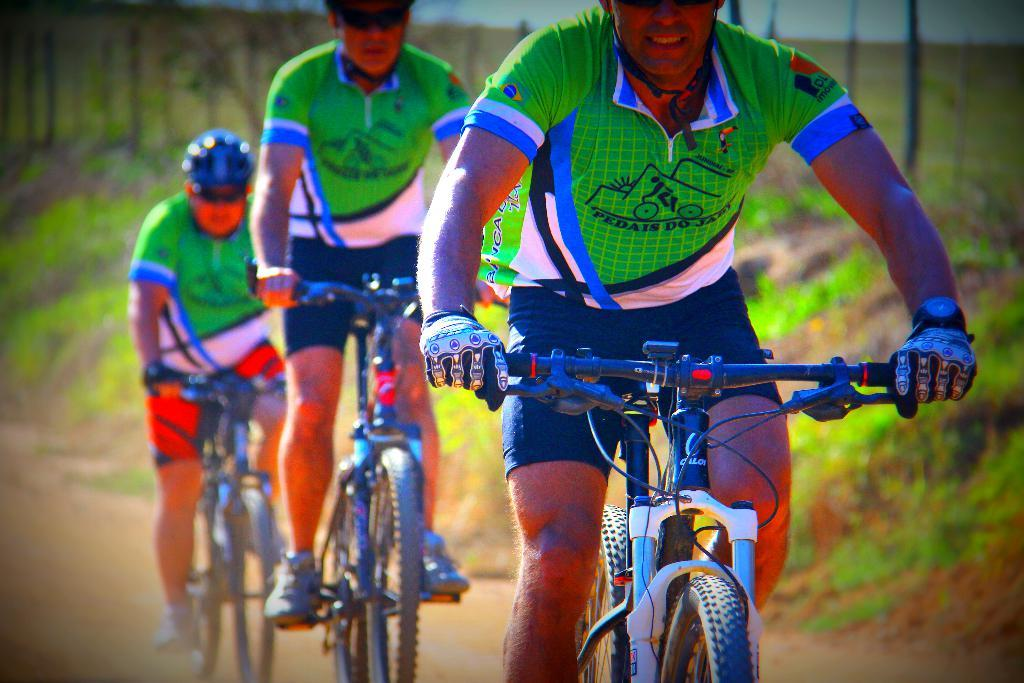How many people are in the image? There are three persons in the image. What are the persons doing in the image? The persons are riding bicycles. What can be seen in the background of the image? There is grass in the background of the image. How would you describe the background of the image? The background of the image is blurred. What is the income of the person riding the bicycle on the left? There is no information about the income of the persons in the image, as it is not relevant to the image's content. 